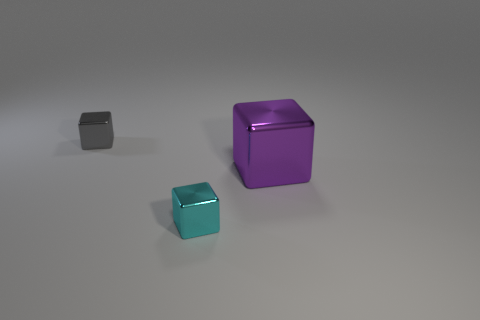Add 3 large purple metal cubes. How many objects exist? 6 Subtract 0 green cubes. How many objects are left? 3 Subtract all tiny cyan metallic cubes. Subtract all tiny objects. How many objects are left? 0 Add 1 cyan things. How many cyan things are left? 2 Add 1 large purple things. How many large purple things exist? 2 